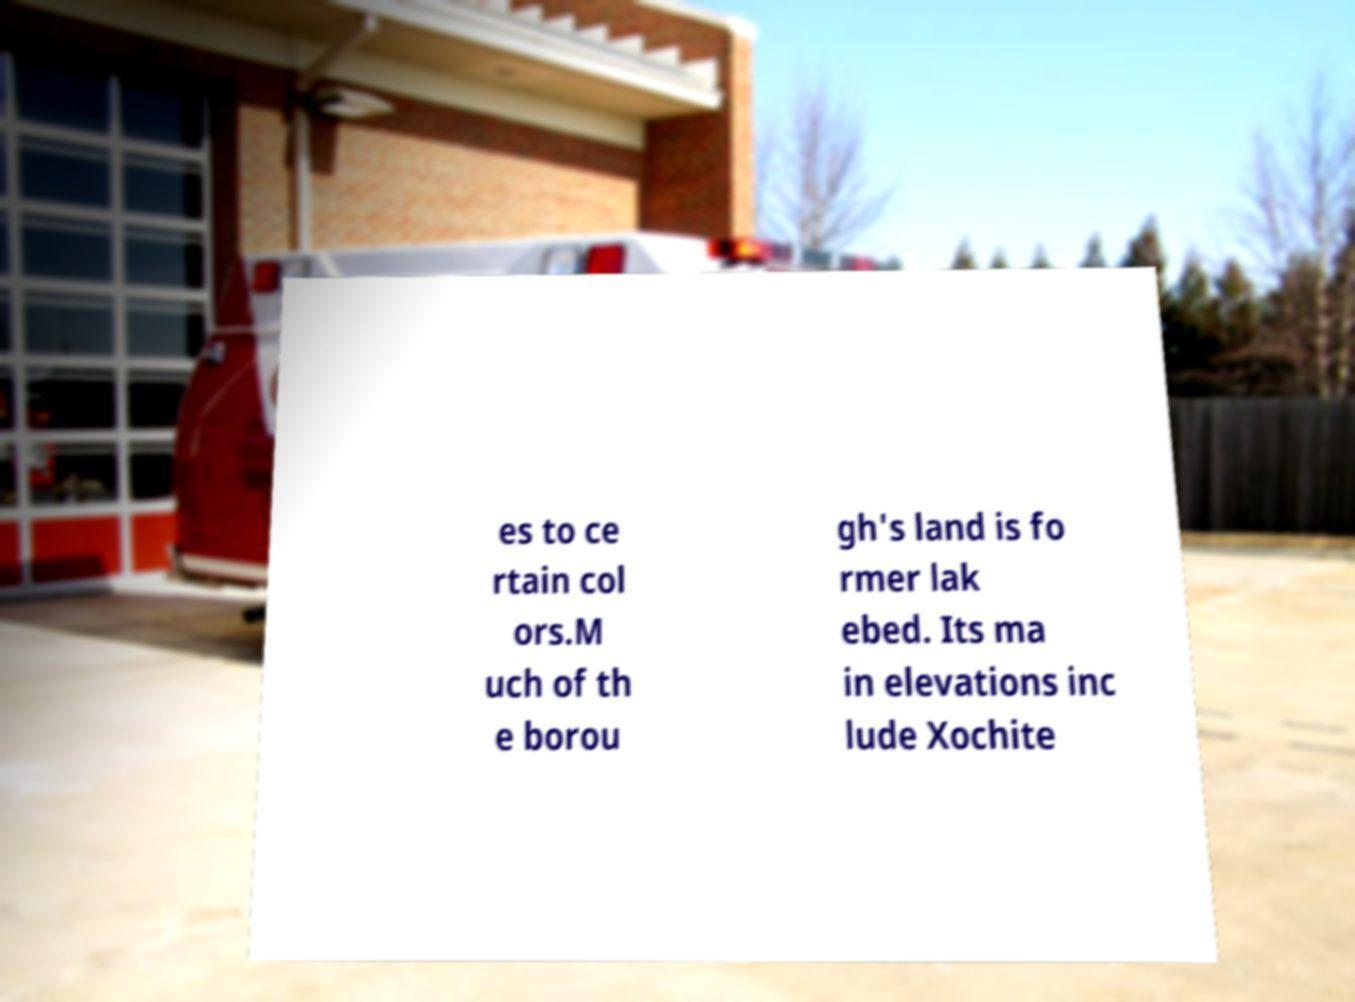Can you accurately transcribe the text from the provided image for me? es to ce rtain col ors.M uch of th e borou gh's land is fo rmer lak ebed. Its ma in elevations inc lude Xochite 